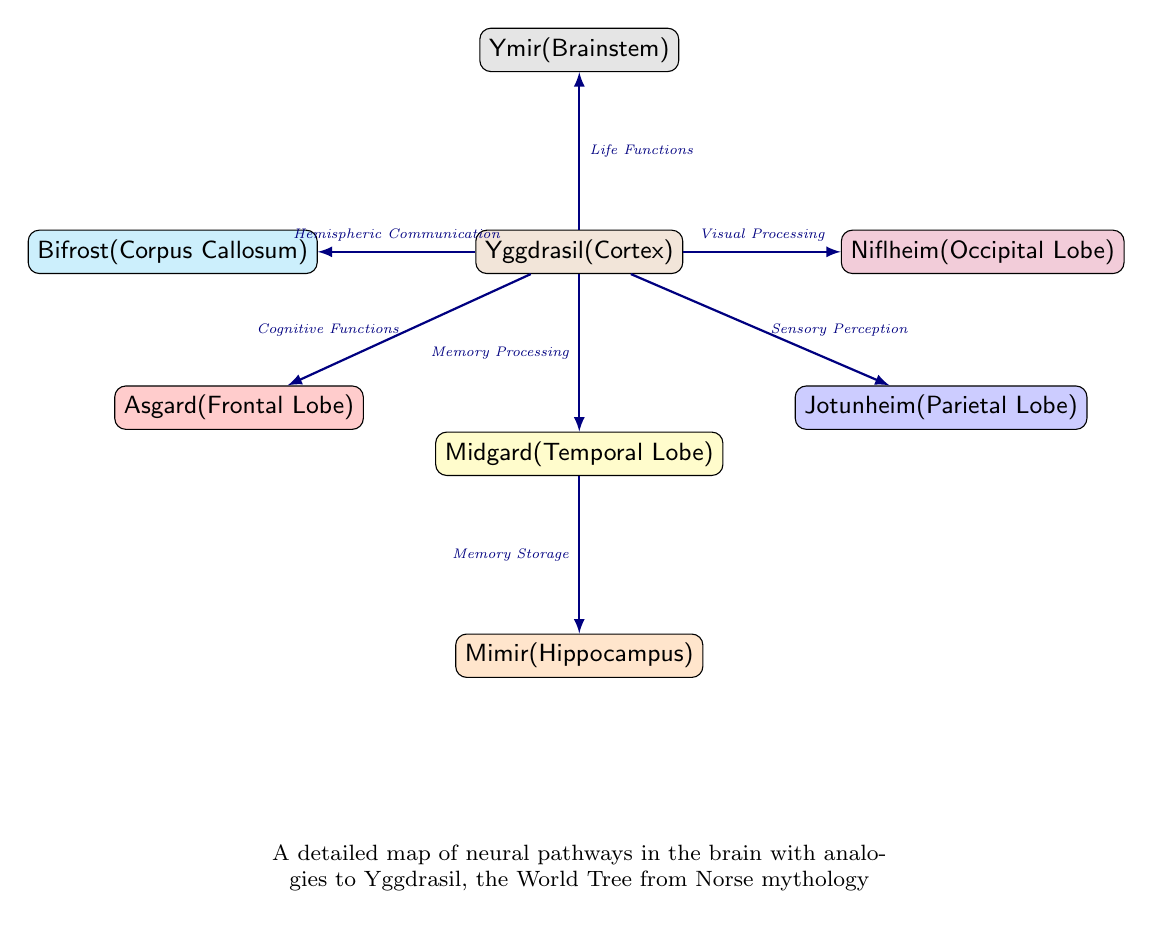What is represented by the node "Yggdrasil"? The node "Yggdrasil" symbolizes the cortex in the brain, suggesting its vital role as the central structure in the neural network depicted in the diagram.
Answer: Cortex How many lobes are depicted in the diagram? Counting the nodes that represent lobes—Frontal, Temporal, Parietal, and Occipital—shows that there are four lobes illustrated in the diagram.
Answer: 4 What pathway connects Midgard and Mimir? The pathway between Midgard (Temporal Lobe) and Mimir (Hippocampus) is labeled as "Memory Storage," indicating its specific function in memory processing.
Answer: Memory Storage Which node represents life functions? The node connected to Yggdrasil that indicates life functions is "Ymir," which symbolizes the brainstem's role in maintaining vital life processes such as breathing and heart rate.
Answer: Ymir What is the connection between Jotunheim and Yggdrasil? Jotunheim connects to Yggdrasil through the pathway labeled "Sensory Perception," showing how sensory information is processed in relation to the cortex.
Answer: Sensory Perception Which part of the diagram represents hemispheric communication? The connection labeled "Hemispheric Communication" in the diagram is represented by the node "Bifrost," indicating its role in facilitating communication between the left and right hemispheres of the brain.
Answer: Bifrost Which lobe corresponds to Asgard in the diagram? Asgard in the diagram corresponds to the Frontal Lobe, indicating its association with higher cognitive functions such as reasoning and planning.
Answer: Frontal Lobe Which node is responsible for visual processing? "Niflheim" in the diagram is the node responsible for visual processing, as denoted by its connection to Yggdrasil labeled "Visual Processing."
Answer: Niflheim Explain the relationship between cognitive functions and Asgard. Cognitive functions are associated with Asgard through the pathway connected to Yggdrasil, indicating that the frontal lobe (Asgard) plays a critical role in various cognitive processes.
Answer: Cognitive Functions 